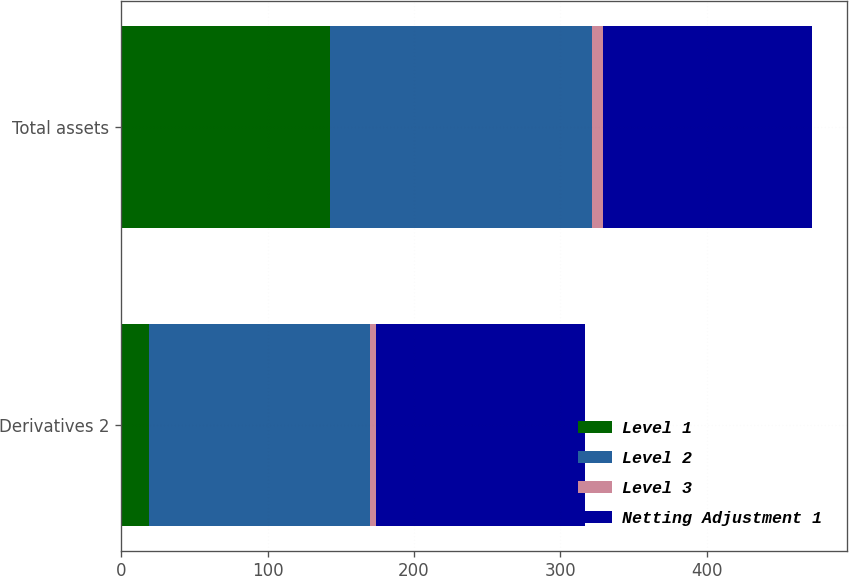Convert chart. <chart><loc_0><loc_0><loc_500><loc_500><stacked_bar_chart><ecel><fcel>Derivatives 2<fcel>Total assets<nl><fcel>Level 1<fcel>19<fcel>143<nl><fcel>Level 2<fcel>151<fcel>179<nl><fcel>Level 3<fcel>4<fcel>7<nl><fcel>Netting Adjustment 1<fcel>143<fcel>143<nl></chart> 